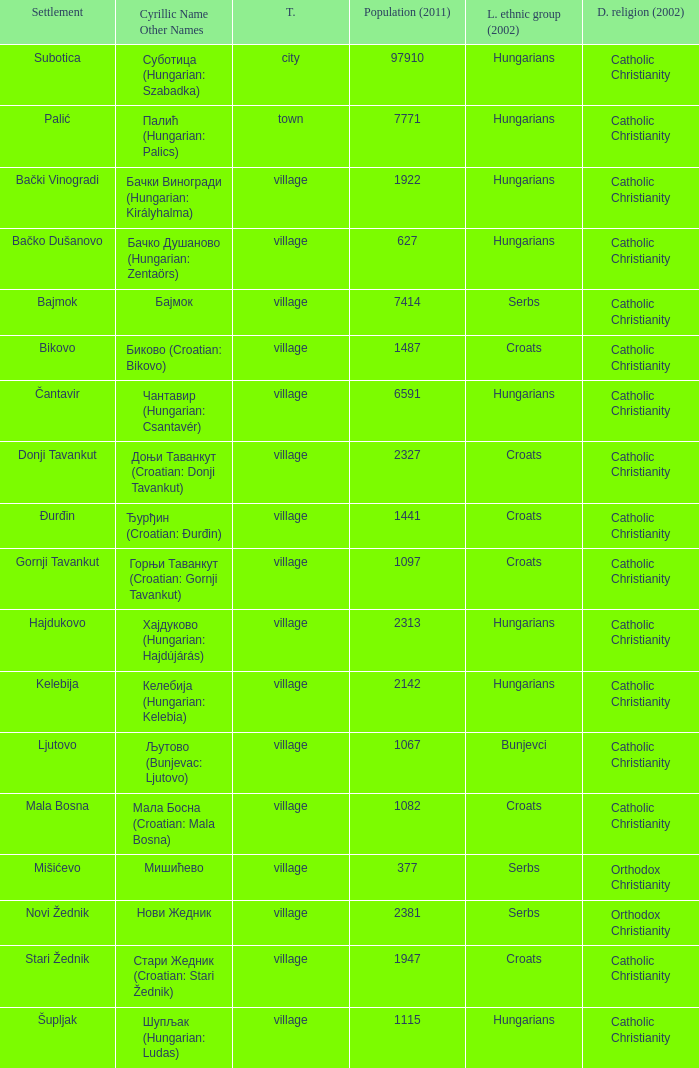What is the dominant religion in Gornji Tavankut? Catholic Christianity. 